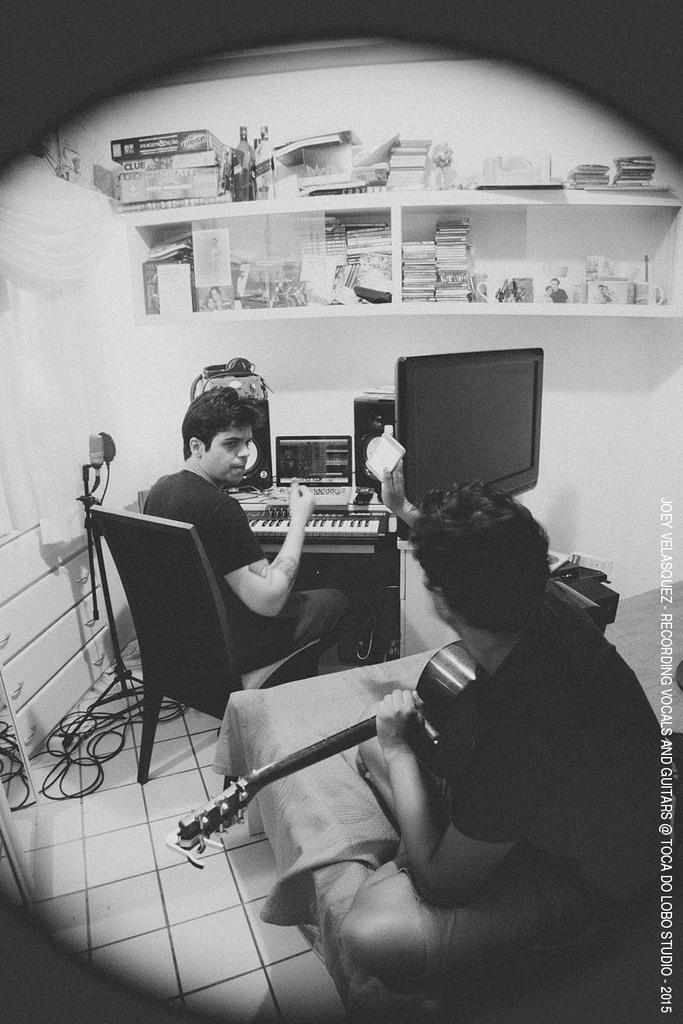Can you describe this image briefly? This is chair and television, here a person is playing guitar, there are objects in the shelf, these are cables on the floor. 